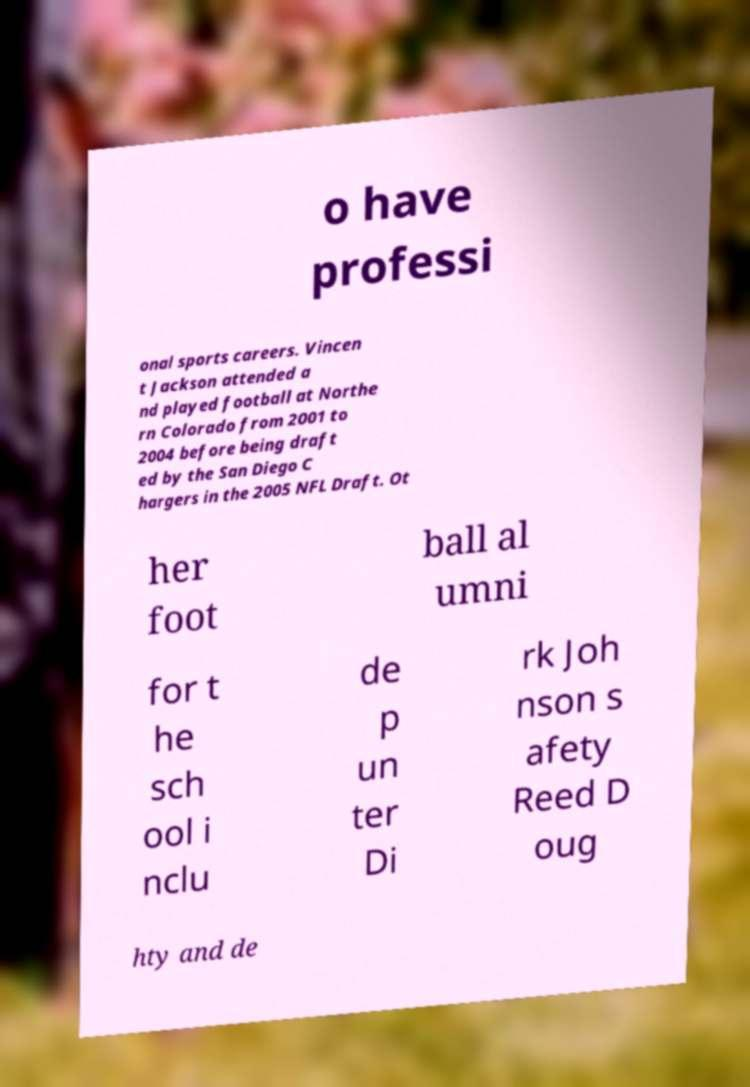Can you accurately transcribe the text from the provided image for me? o have professi onal sports careers. Vincen t Jackson attended a nd played football at Northe rn Colorado from 2001 to 2004 before being draft ed by the San Diego C hargers in the 2005 NFL Draft. Ot her foot ball al umni for t he sch ool i nclu de p un ter Di rk Joh nson s afety Reed D oug hty and de 